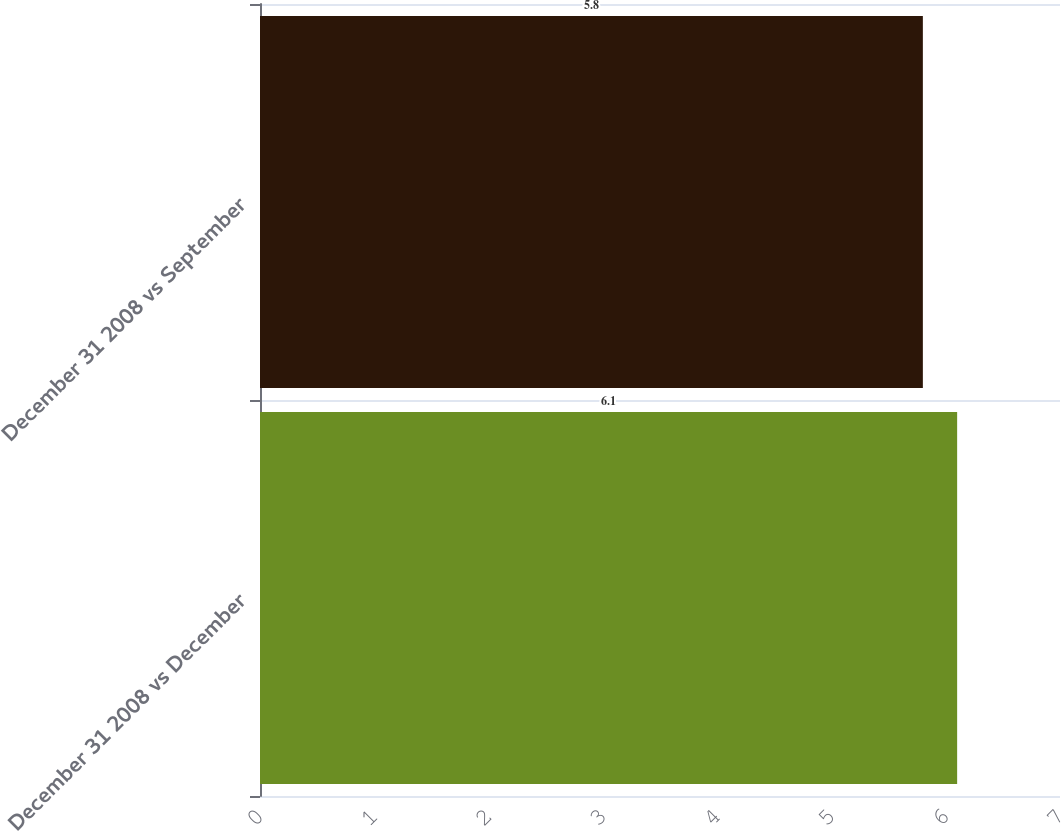Convert chart. <chart><loc_0><loc_0><loc_500><loc_500><bar_chart><fcel>December 31 2008 vs December<fcel>December 31 2008 vs September<nl><fcel>6.1<fcel>5.8<nl></chart> 